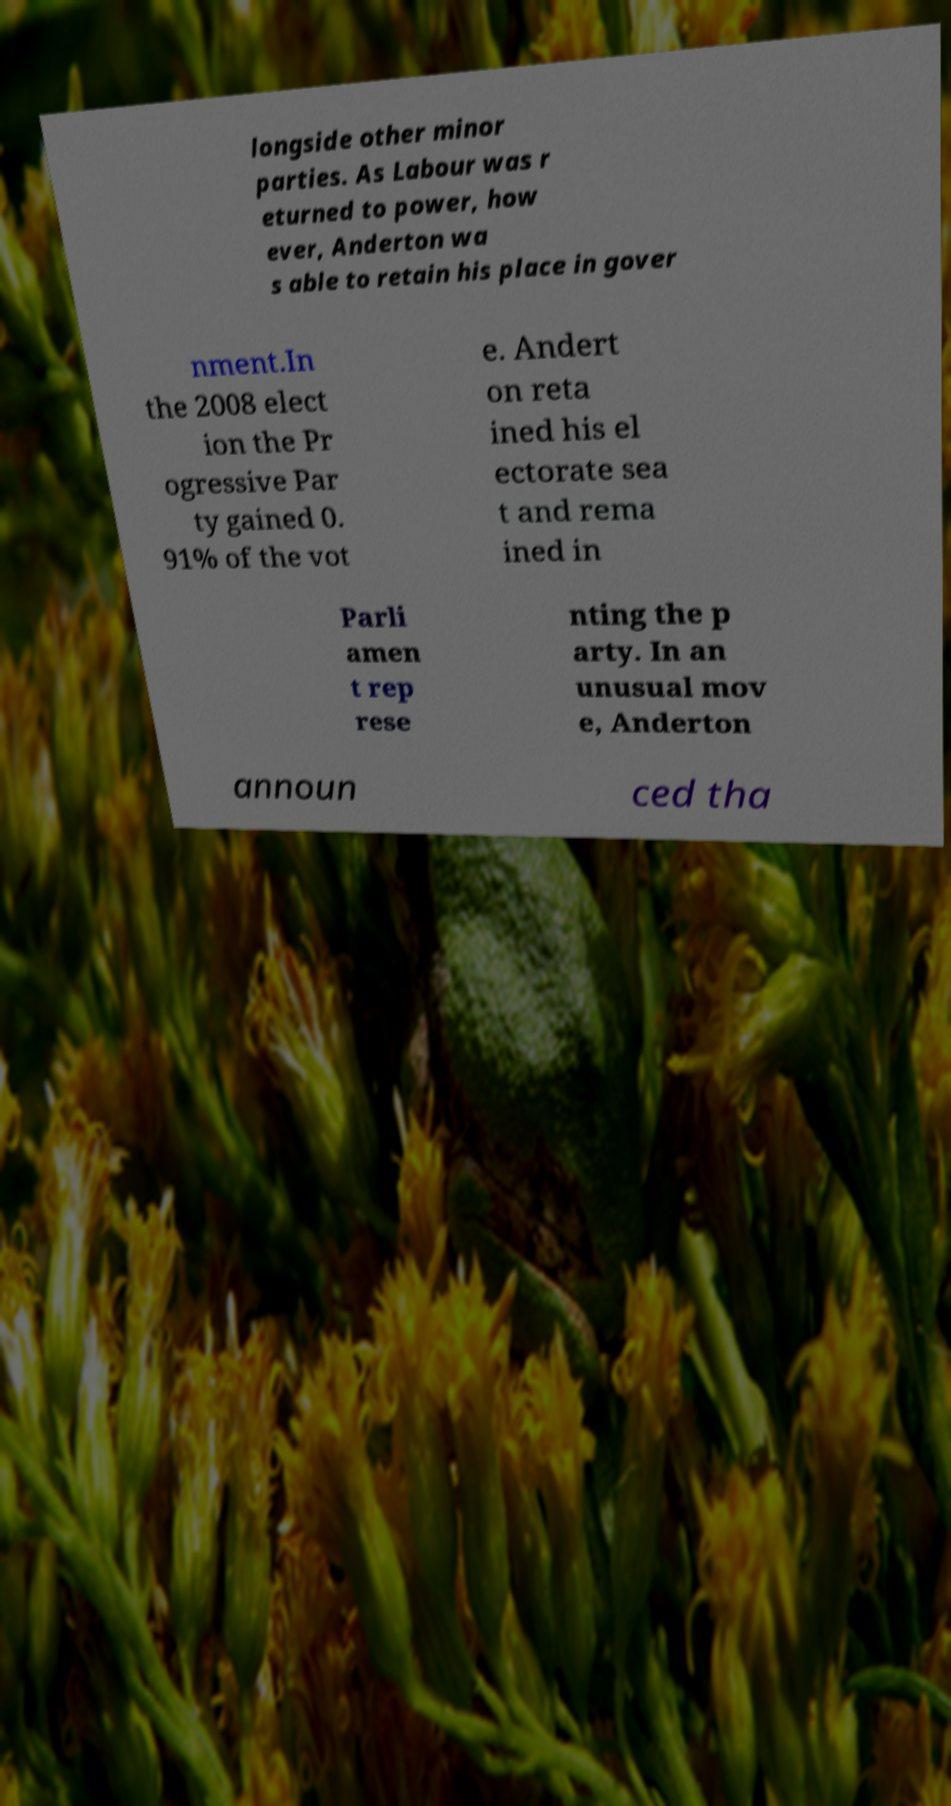Could you assist in decoding the text presented in this image and type it out clearly? longside other minor parties. As Labour was r eturned to power, how ever, Anderton wa s able to retain his place in gover nment.In the 2008 elect ion the Pr ogressive Par ty gained 0. 91% of the vot e. Andert on reta ined his el ectorate sea t and rema ined in Parli amen t rep rese nting the p arty. In an unusual mov e, Anderton announ ced tha 